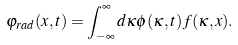Convert formula to latex. <formula><loc_0><loc_0><loc_500><loc_500>\varphi _ { r a d } ( x , t ) = \int _ { - \infty } ^ { \infty } d \kappa \phi ( \kappa , t ) f ( \kappa , x ) .</formula> 